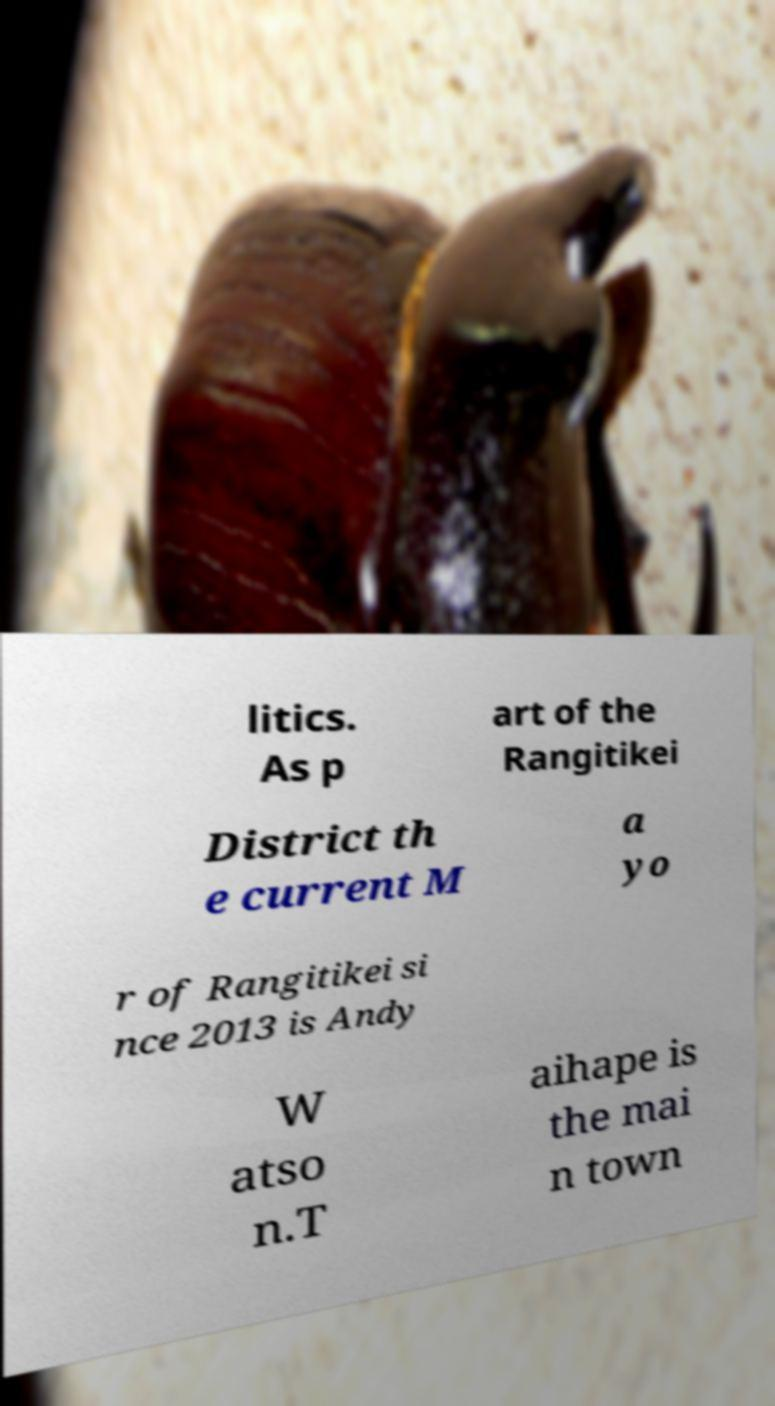Please read and relay the text visible in this image. What does it say? litics. As p art of the Rangitikei District th e current M a yo r of Rangitikei si nce 2013 is Andy W atso n.T aihape is the mai n town 